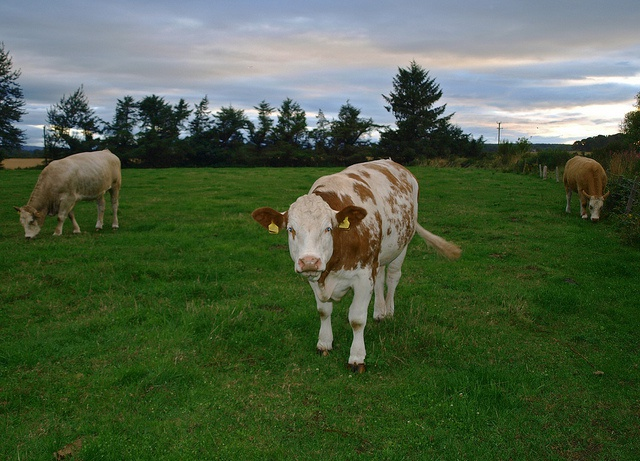Describe the objects in this image and their specific colors. I can see cow in gray, darkgray, maroon, and olive tones, cow in gray, darkgreen, and black tones, and cow in gray, black, maroon, and olive tones in this image. 